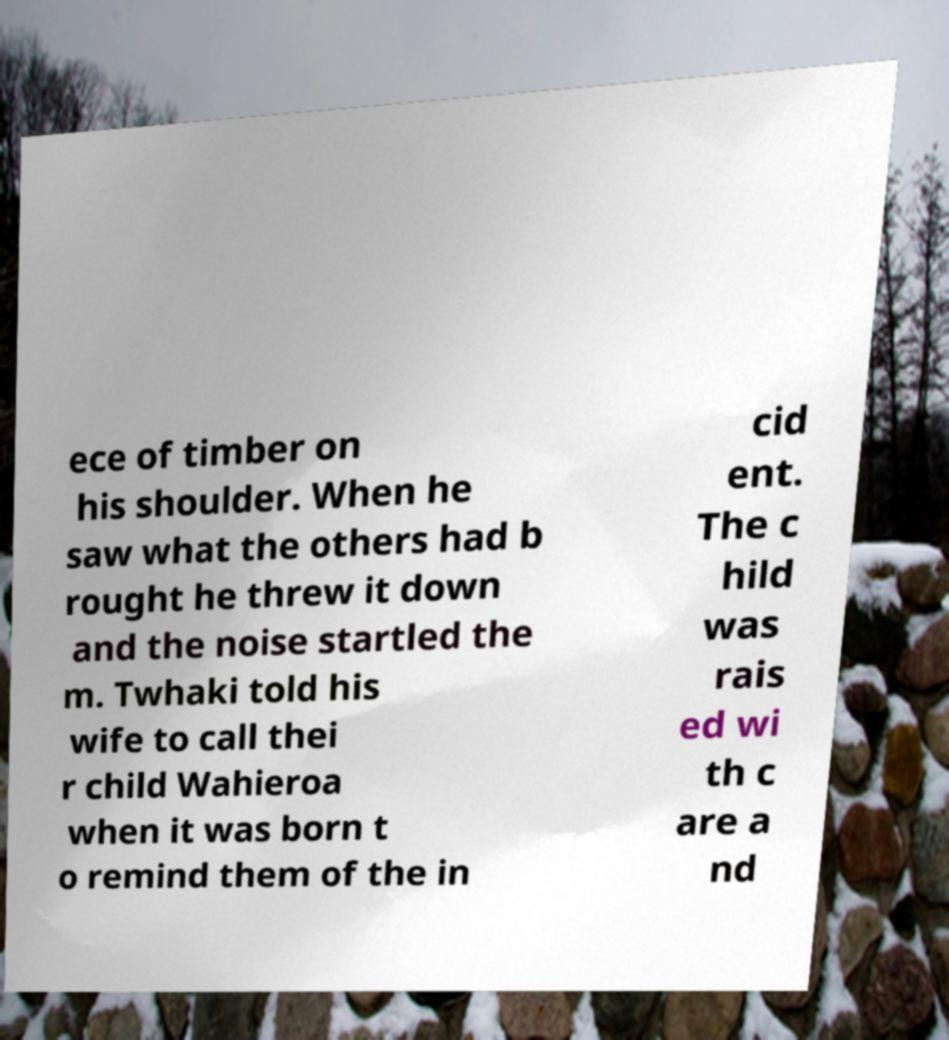Can you accurately transcribe the text from the provided image for me? ece of timber on his shoulder. When he saw what the others had b rought he threw it down and the noise startled the m. Twhaki told his wife to call thei r child Wahieroa when it was born t o remind them of the in cid ent. The c hild was rais ed wi th c are a nd 